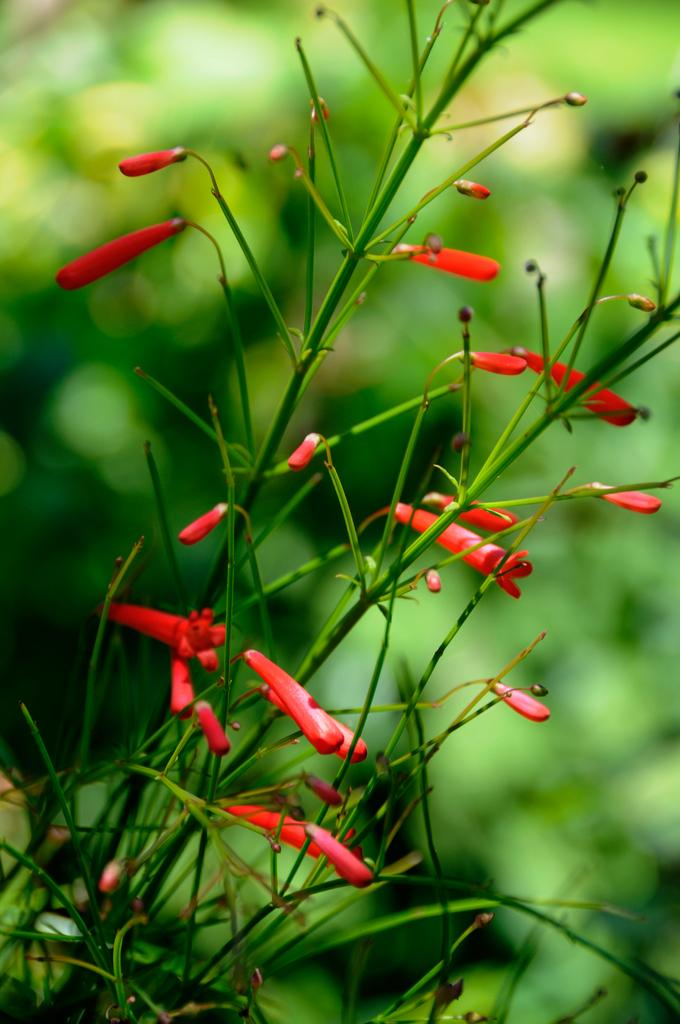What is located in the front of the image? There are plants in the front of the image. What type of flowers can be seen in the image? There are red color flowers in the image. How would you describe the background of the image? The background of the image is blurred. How many stars can be seen in the image? There are no stars present in the image; it features plants and flowers. What type of base is supporting the passenger in the image? There is no passenger or base present in the image; it only contains plants and flowers. 